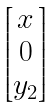<formula> <loc_0><loc_0><loc_500><loc_500>\begin{bmatrix} x \\ 0 \\ y _ { 2 } \end{bmatrix}</formula> 